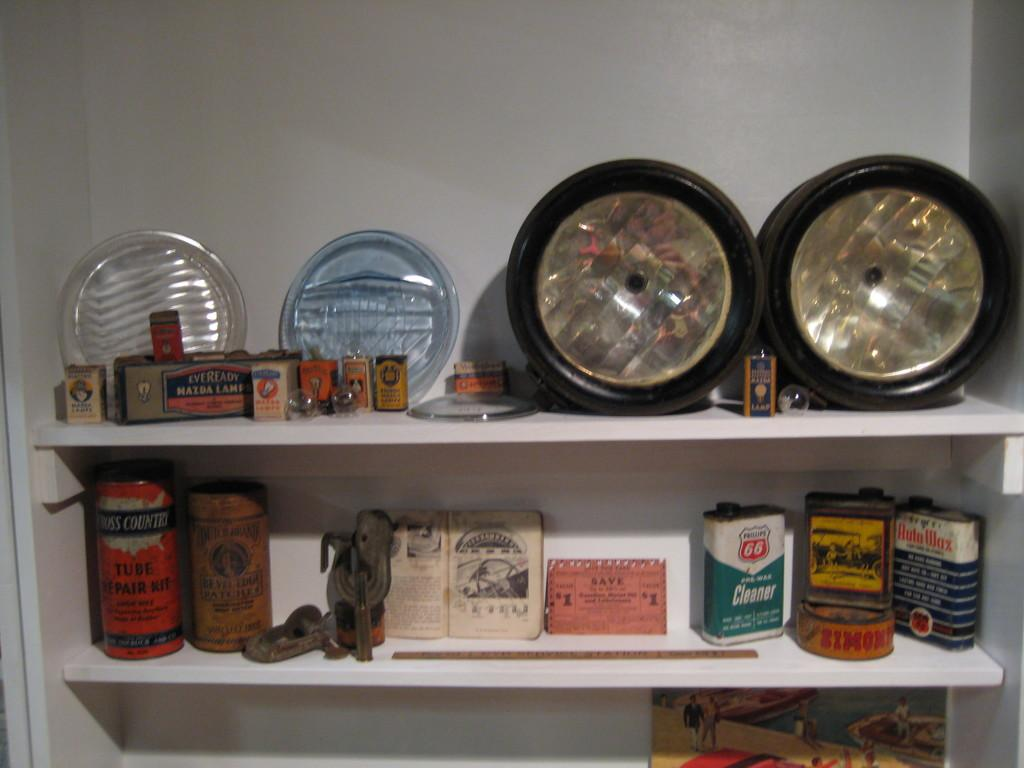<image>
Provide a brief description of the given image. Various antique items on shelves and one of them is a cleaner from Phillips 66. 